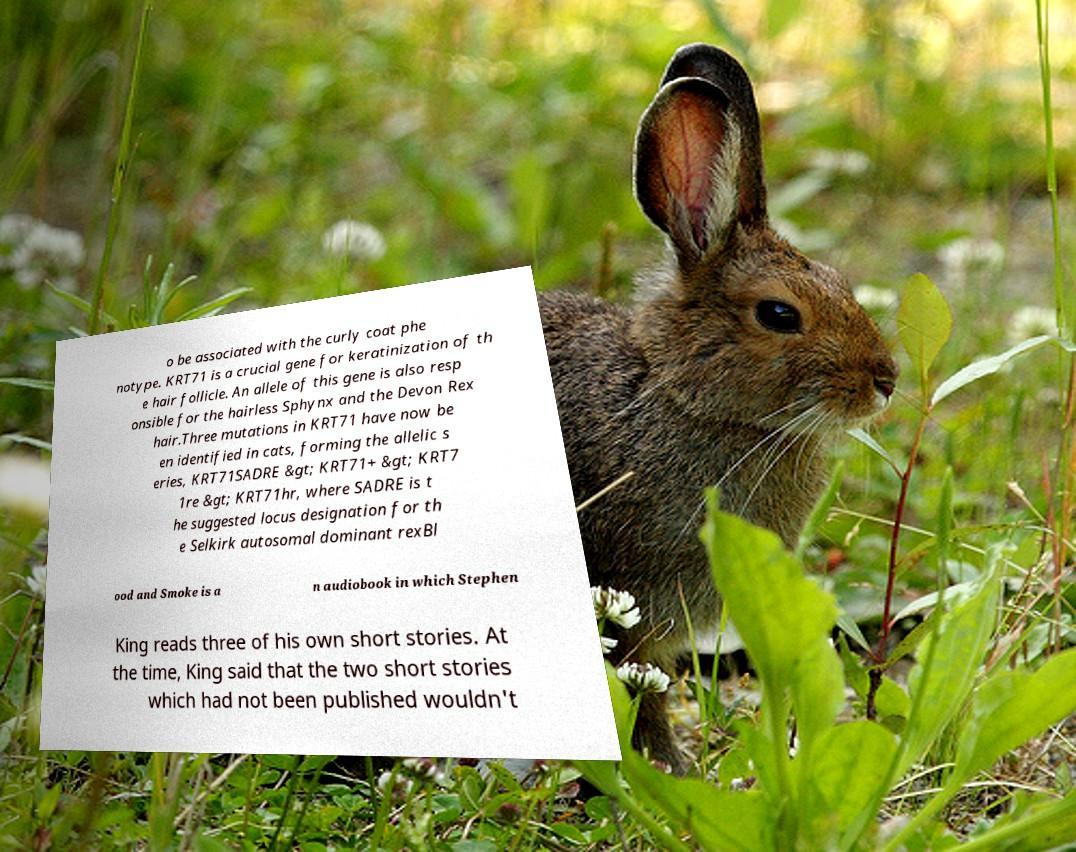I need the written content from this picture converted into text. Can you do that? o be associated with the curly coat phe notype. KRT71 is a crucial gene for keratinization of th e hair follicle. An allele of this gene is also resp onsible for the hairless Sphynx and the Devon Rex hair.Three mutations in KRT71 have now be en identified in cats, forming the allelic s eries, KRT71SADRE &gt; KRT71+ &gt; KRT7 1re &gt; KRT71hr, where SADRE is t he suggested locus designation for th e Selkirk autosomal dominant rexBl ood and Smoke is a n audiobook in which Stephen King reads three of his own short stories. At the time, King said that the two short stories which had not been published wouldn't 